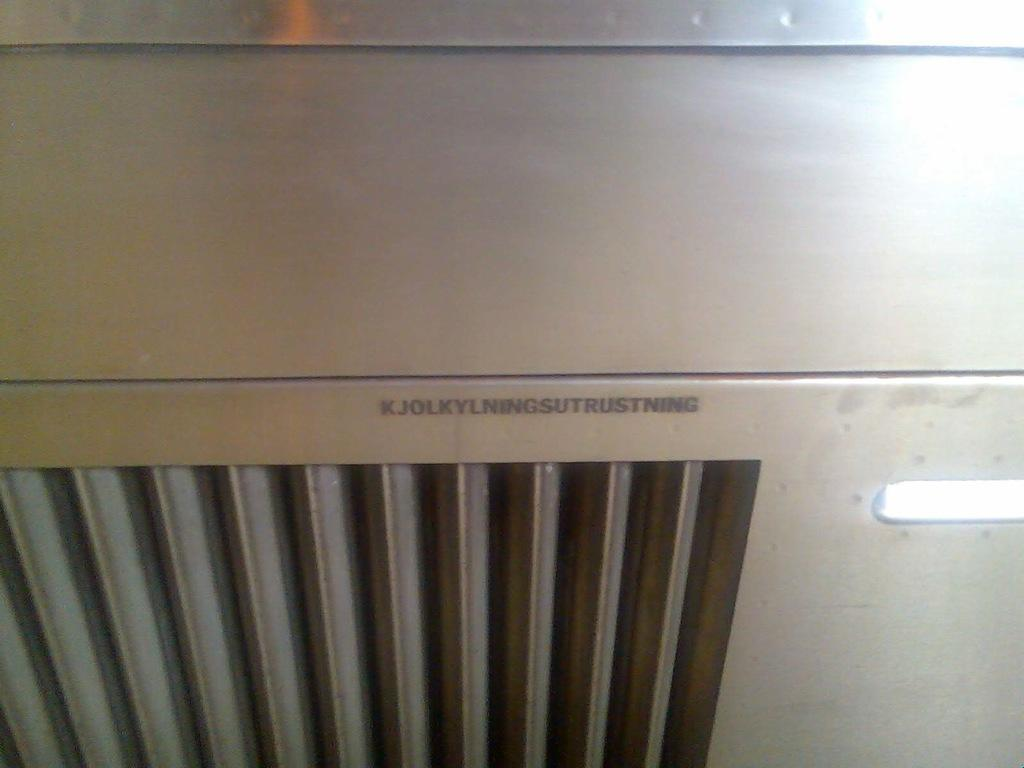Provide a one-sentence caption for the provided image. Furnace with a name starting with a k. 